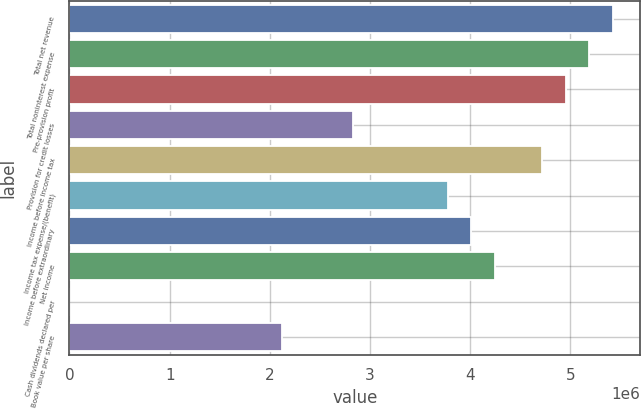Convert chart. <chart><loc_0><loc_0><loc_500><loc_500><bar_chart><fcel>Total net revenue<fcel>Total noninterest expense<fcel>Pre-provision profit<fcel>Provision for credit losses<fcel>Income before income tax<fcel>Income tax expense/(benefit)<fcel>Income before extraordinary<fcel>Net income<fcel>Cash dividends declared per<fcel>Book value per share<nl><fcel>5.42602e+06<fcel>5.19011e+06<fcel>4.95419e+06<fcel>2.83097e+06<fcel>4.71828e+06<fcel>3.77462e+06<fcel>4.01054e+06<fcel>4.24645e+06<fcel>1.2<fcel>2.12323e+06<nl></chart> 